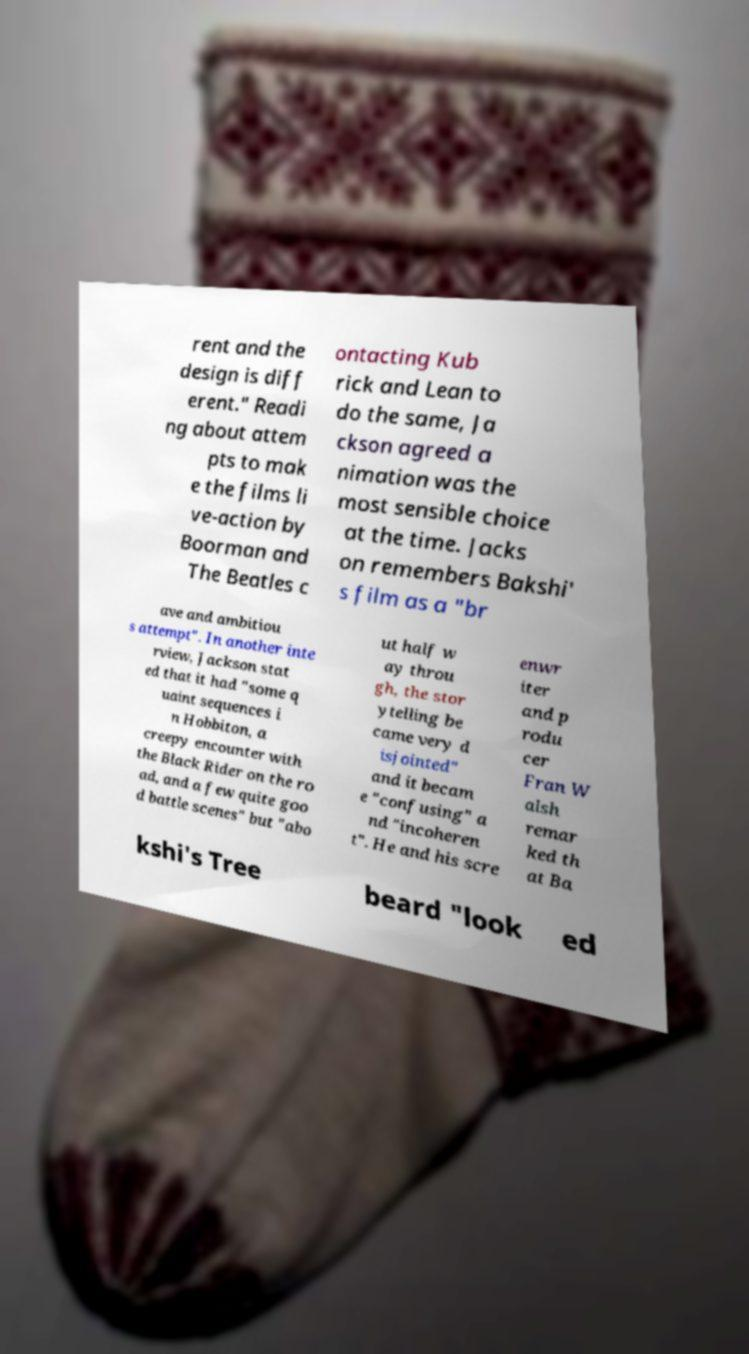Please identify and transcribe the text found in this image. rent and the design is diff erent." Readi ng about attem pts to mak e the films li ve-action by Boorman and The Beatles c ontacting Kub rick and Lean to do the same, Ja ckson agreed a nimation was the most sensible choice at the time. Jacks on remembers Bakshi' s film as a "br ave and ambitiou s attempt". In another inte rview, Jackson stat ed that it had "some q uaint sequences i n Hobbiton, a creepy encounter with the Black Rider on the ro ad, and a few quite goo d battle scenes" but "abo ut half w ay throu gh, the stor ytelling be came very d isjointed" and it becam e "confusing" a nd "incoheren t". He and his scre enwr iter and p rodu cer Fran W alsh remar ked th at Ba kshi's Tree beard "look ed 